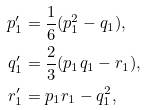<formula> <loc_0><loc_0><loc_500><loc_500>p _ { 1 } ^ { \prime } & = \frac { 1 } { 6 } ( p _ { 1 } ^ { 2 } - q _ { 1 } ) , \\ q _ { 1 } ^ { \prime } & = \frac { 2 } { 3 } ( p _ { 1 } q _ { 1 } - r _ { 1 } ) , \\ r _ { 1 } ^ { \prime } & = p _ { 1 } r _ { 1 } - q _ { 1 } ^ { 2 } ,</formula> 